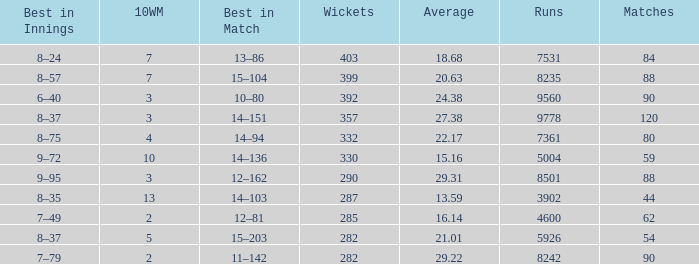Could you parse the entire table? {'header': ['Best in Innings', '10WM', 'Best in Match', 'Wickets', 'Average', 'Runs', 'Matches'], 'rows': [['8–24', '7', '13–86', '403', '18.68', '7531', '84'], ['8–57', '7', '15–104', '399', '20.63', '8235', '88'], ['6–40', '3', '10–80', '392', '24.38', '9560', '90'], ['8–37', '3', '14–151', '357', '27.38', '9778', '120'], ['8–75', '4', '14–94', '332', '22.17', '7361', '80'], ['9–72', '10', '14–136', '330', '15.16', '5004', '59'], ['9–95', '3', '12–162', '290', '29.31', '8501', '88'], ['8–35', '13', '14–103', '287', '13.59', '3902', '44'], ['7–49', '2', '12–81', '285', '16.14', '4600', '62'], ['8–37', '5', '15–203', '282', '21.01', '5926', '54'], ['7–79', '2', '11–142', '282', '29.22', '8242', '90']]} How many wickets possess runs fewer than 7531, matches exceeding 44, and a mean of 2 332.0. 